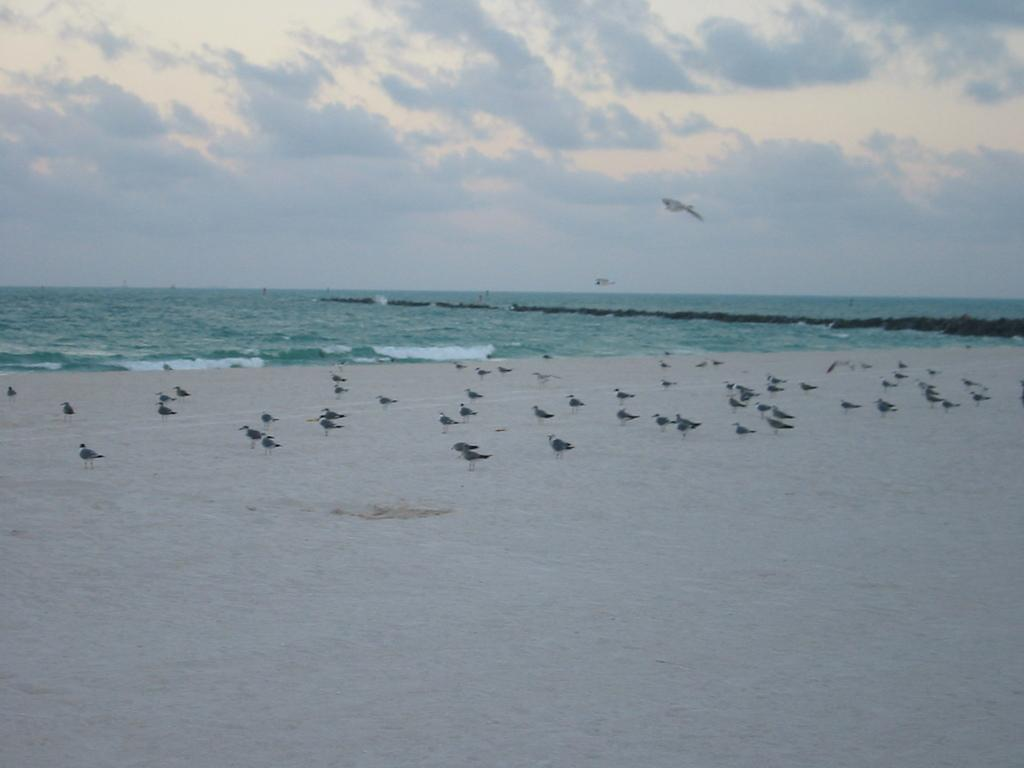What type of animals can be seen in the image? There are birds in the image. Where are the birds located? The birds are on sand at the beach. What can be seen in the background of the image? There is water and a cloudy sky visible in the background of the image. What type of pickle is the bear holding in the image? There is no bear or pickle present in the image; it features birds on sand at the beach with a cloudy sky in the background. 